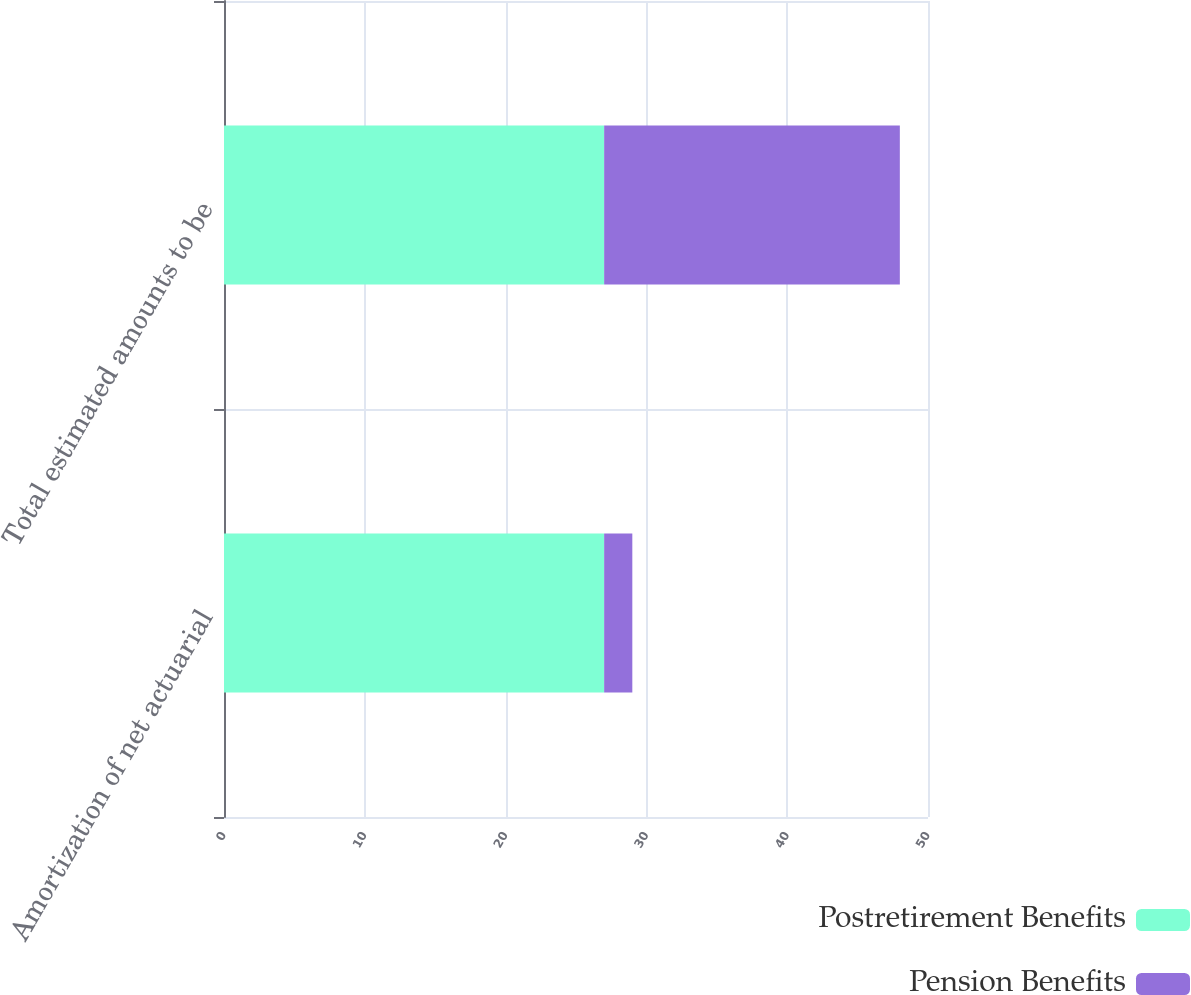Convert chart. <chart><loc_0><loc_0><loc_500><loc_500><stacked_bar_chart><ecel><fcel>Amortization of net actuarial<fcel>Total estimated amounts to be<nl><fcel>Postretirement Benefits<fcel>27<fcel>27<nl><fcel>Pension Benefits<fcel>2<fcel>21<nl></chart> 